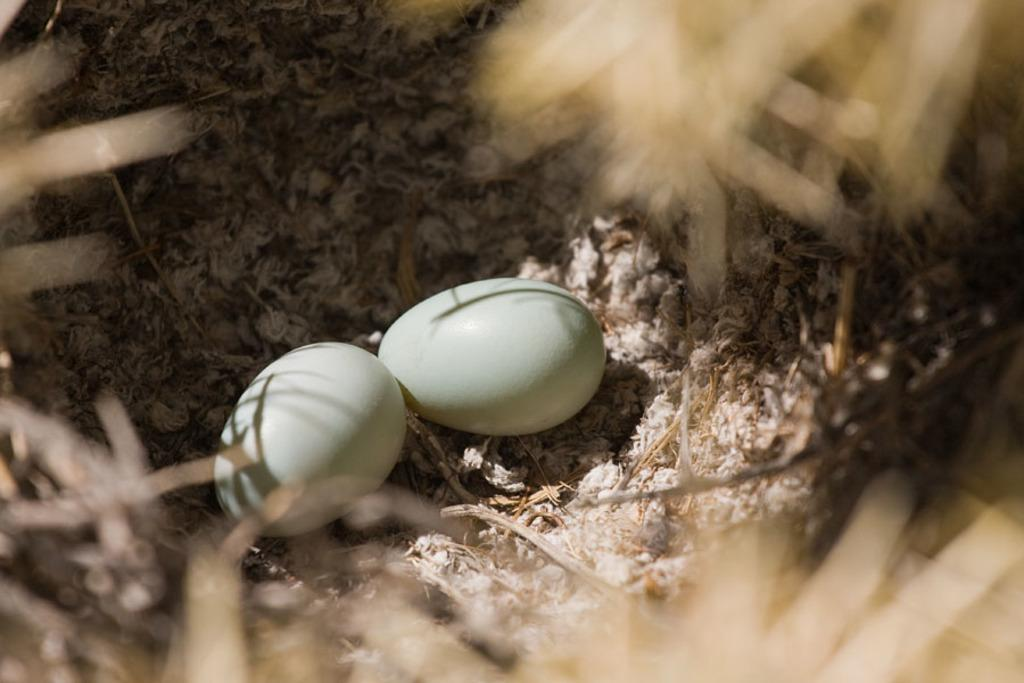What objects are on the ground in the image? There are two eggs present on the ground in the image. Can you describe the surroundings of the eggs in the image? The surroundings of the eggs are blurry in the image. What type of memory can be seen in the image? There is no memory present in the image; it features two eggs on the ground with blurry surroundings. 